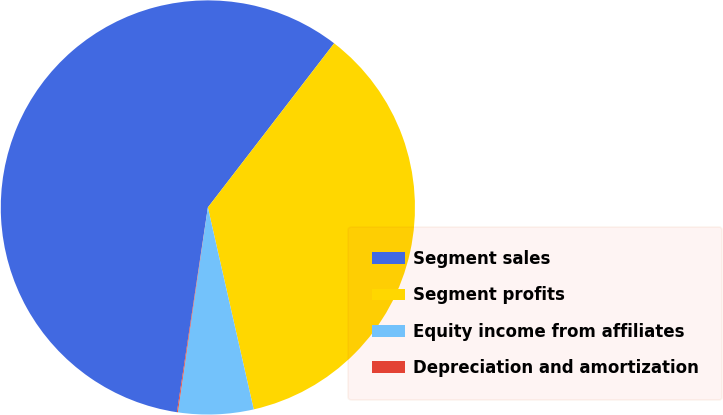Convert chart. <chart><loc_0><loc_0><loc_500><loc_500><pie_chart><fcel>Segment sales<fcel>Segment profits<fcel>Equity income from affiliates<fcel>Depreciation and amortization<nl><fcel>58.05%<fcel>36.01%<fcel>5.87%<fcel>0.07%<nl></chart> 